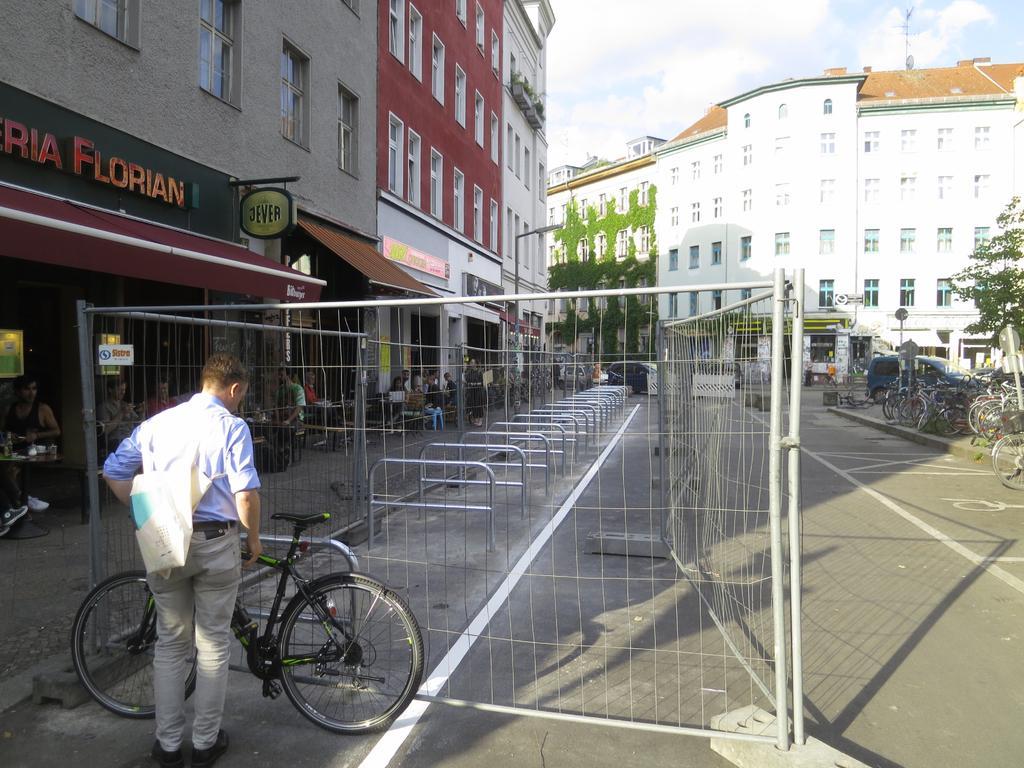In one or two sentences, can you explain what this image depicts? In this image we can see a person standing near the bicycle, there is a fence, few metal rods, buildings with text and a building with creeper plants, there is a street light in front of the building, there are few people sitting near the buildings and there is a table with some objects on the left side and there are few bicycles, two poles with boards on the pavement and few vehicles on the road and there is a tree on the right side and the sky with clouds in the background. 